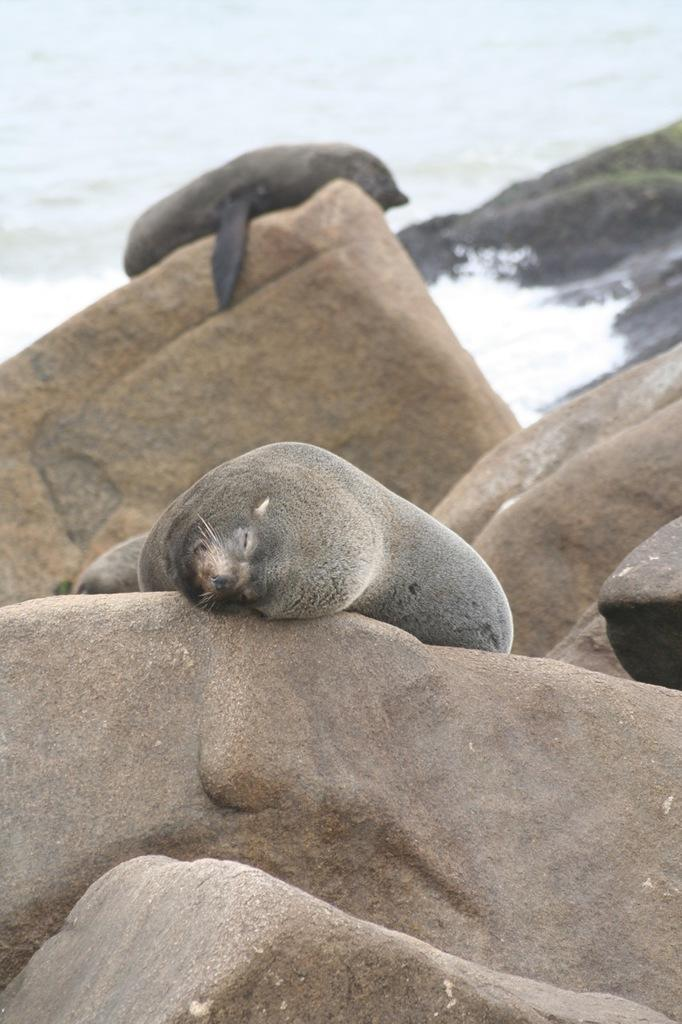What animals are present in the image? There are two seals in the image. What are the seals doing in the image? The seals are laying on large stones. What color are the seals? The seals are grey in color. What can be seen in the background of the image? There is an ocean visible in the background of the image. How many frogs can be seen hopping around the seals in the image? There are no frogs present in the image; it features two seals laying on large stones. What type of trip are the seals planning to take in the image? The seals are not planning a trip in the image; they are simply laying on large stones. 